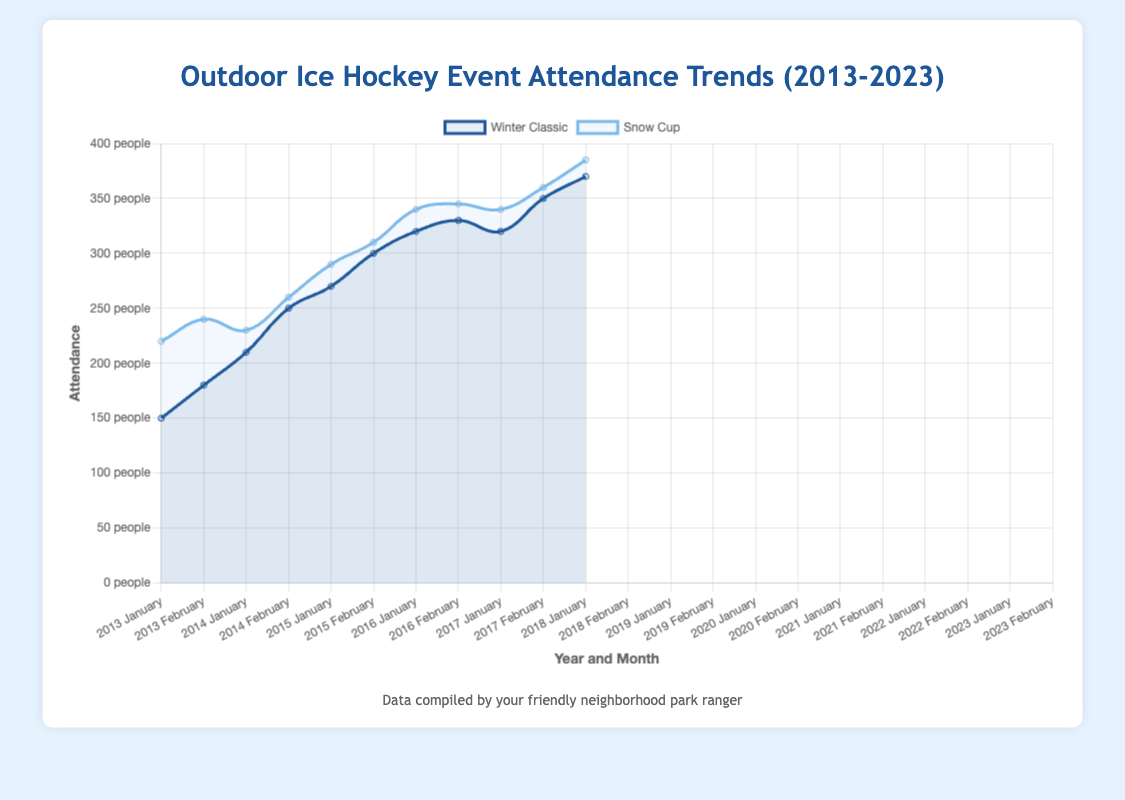Which event had higher attendance in January 2013, Winter Classic or Snow Cup? Visual inspection shows "Winter Classic" in January 2013 has an attendance of 150, while "Snow Cup" in February 2013 has an attendance of 220. Thus, "Snow Cup" had higher attendance.
Answer: Snow Cup What is the overall trend from 2013 to 2023 for the Winter Classic event? Observing the data points for the Winter Classic event from 2013 (150) to 2023 (370), the attendance shows an upward trend with minor fluctuations around the years 2019-2021.
Answer: Upward trend How did the attendance of the Snow Cup in 2015 compare to the attendance of the Winter Classic in the same year? In 2015, the attendance for the Snow Cup in February was 230, while for the Winter Classic in January, it was 210. Thus, the Snow Cup had higher attendance in 2015.
Answer: Snow Cup had higher attendance Calculate the average attendance for the Winter Classic from 2016 to 2020. Sum of attendance from 2016 to 2020: 250 + 270 + 300 + 320 + 330 = 1470. Divide by the number of events (5): 1470 / 5 = 294.
Answer: 294 Which month and year saw the highest attendance for the Snow Cup? By visually inspecting the highest peaks for Snow Cup, February 2023 had the highest attendance at 385.
Answer: February 2023 What is the maximum increase in attendance for the Winter Classic from one year to the next? Calculate the yearly increases: 2014 (180-150=30), 2015 (210-180=30), 2016 (250-210=40), 2017 (270-250=20), 2018 (300-270=30), 2019 (320-300=20), 2020 (330-320=10), 2021 (320-330=-10), 2022 (350-320=30), 2023 (370-350=20). The maximum increase is 40 from 2015 to 2016.
Answer: 40 In which year did the attendance for the Winter Classic and Snow Cup both exceed 300? Visual inspection shows that in 2018, 2019, 2020, 2022, and 2023, the attendance for both events exceeded 300, but it first happened in 2018.
Answer: 2018 How does the attendance trend for the Snow Cup compare to that of the Winter Classic? Both trends show a general increase in attendance from 2013 to 2023, though the Snow Cup's increase appears more consistent and less volatile than the Winter Classic's trend.
Answer: Both show an increasing trend, Snow Cup is more consistent Summarize the key differences in attendance trends between the events held in Denver and those held in New York. Denver (Winter Classic until 2017) shows a steady increase from 150 (2013) to 270 (2017). New York (Winter Classic from 2018) starts high at 300 and fluctuates but generally remains above 300.
Answer: Denver: steady increase; New York: higher start, fluctuating What was the total attendance for all events in the year 2023? Sum of attendances for both Winter Classic and Snow Cup in 2023: 370 (Winter Classic) + 385 (Snow Cup) = 755.
Answer: 755 